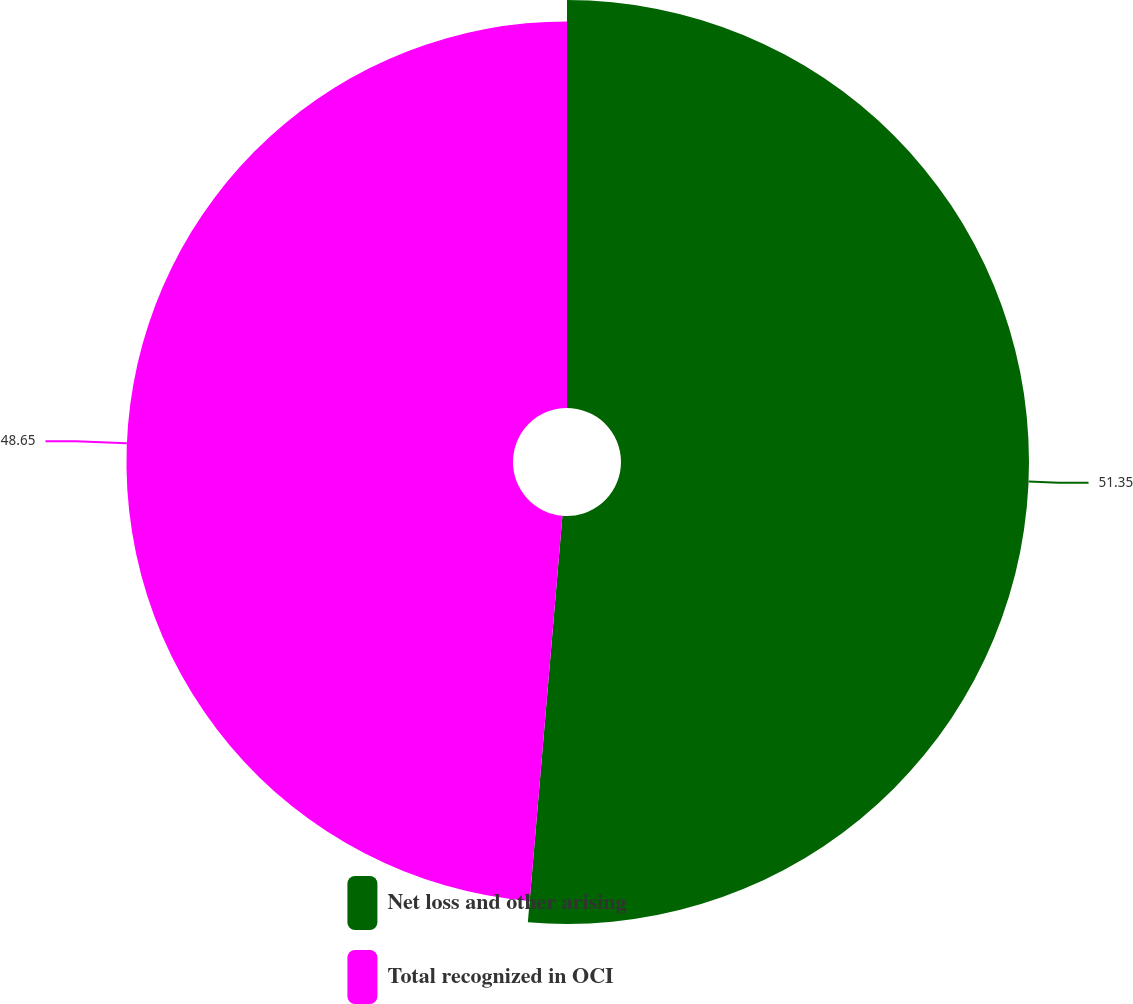Convert chart. <chart><loc_0><loc_0><loc_500><loc_500><pie_chart><fcel>Net loss and other arising<fcel>Total recognized in OCI<nl><fcel>51.35%<fcel>48.65%<nl></chart> 